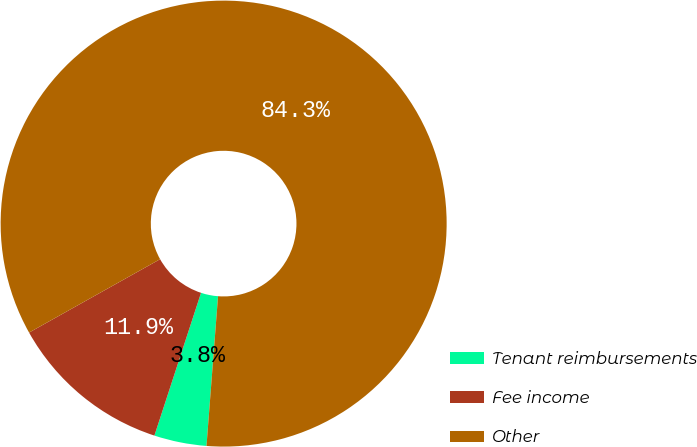<chart> <loc_0><loc_0><loc_500><loc_500><pie_chart><fcel>Tenant reimbursements<fcel>Fee income<fcel>Other<nl><fcel>3.8%<fcel>11.85%<fcel>84.35%<nl></chart> 